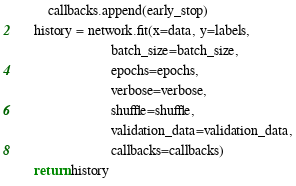Convert code to text. <code><loc_0><loc_0><loc_500><loc_500><_Python_>        callbacks.append(early_stop)
    history = network.fit(x=data, y=labels,
                          batch_size=batch_size,
                          epochs=epochs,
                          verbose=verbose,
                          shuffle=shuffle,
                          validation_data=validation_data,
                          callbacks=callbacks)
    return history
</code> 